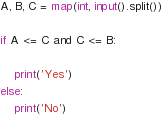<code> <loc_0><loc_0><loc_500><loc_500><_Python_>A, B, C = map(int, input().split())

if A <= C and C <= B:

    print('Yes')
else:
    print('No')</code> 